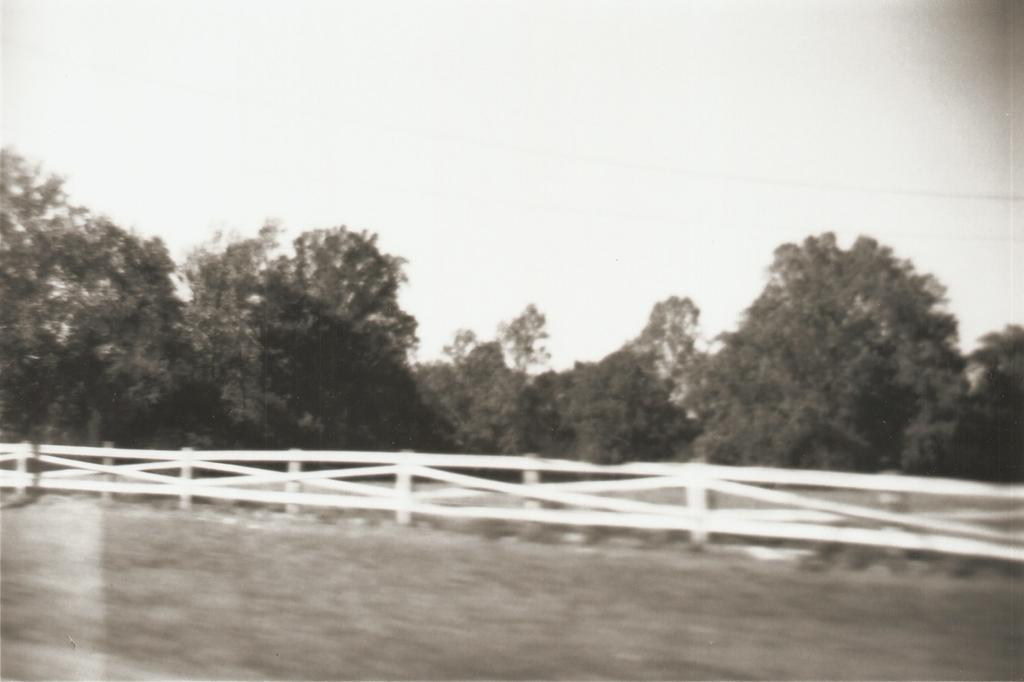What type of vegetation is in the foreground of the image? There is grass in the foreground of the image. What structure can be seen in the middle of the image? There is railing in the middle of the image. What type of vegetation is in the background of the image? There are trees in the background of the image. What is visible in the background of the image? The sky is visible in the background of the image. Can you see a zebra grazing on the grass in the image? No, there is no zebra present in the image. What type of horn is attached to the railing in the image? There is no horn attached to the railing in the image. 